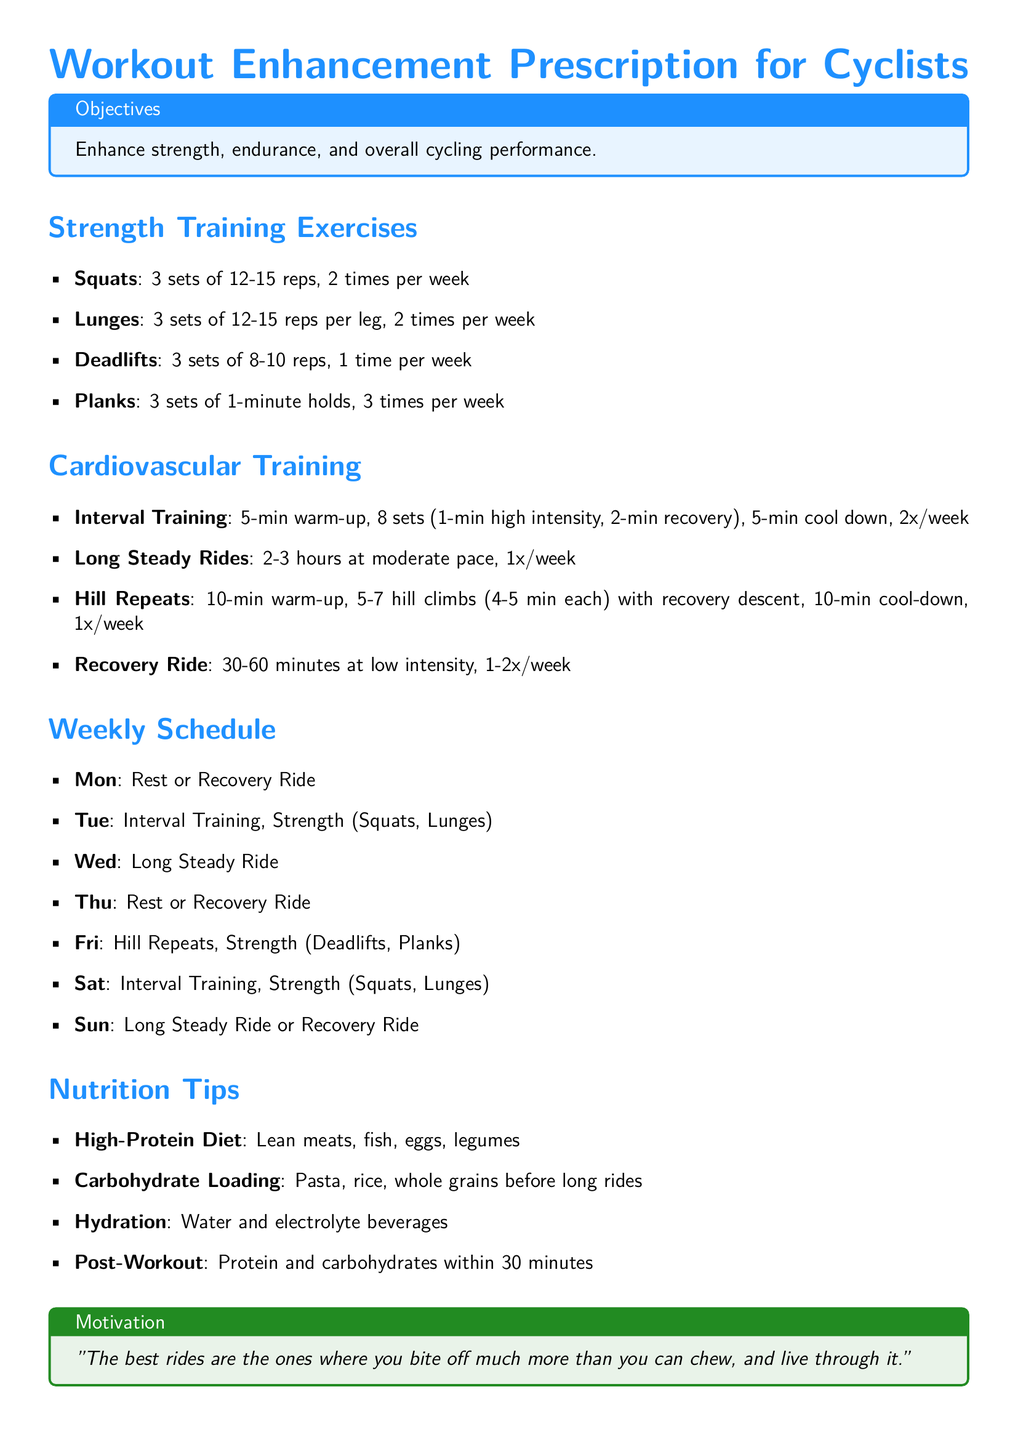What is the primary objective of the workout prescription? The objective stated in the document is to enhance strength, endurance, and overall cycling performance.
Answer: Enhance strength, endurance, and overall cycling performance How many sets of lunges should be performed per week? The document specifies that lunges should be performed for 3 sets, 2 times per week.
Answer: 2 times per week What is the duration for the long steady rides? The document indicates that long steady rides should be 2-3 hours at a moderate pace.
Answer: 2-3 hours How many hill climbs are recommended during hill repeats? The recommendation for hill repeats is 5-7 hill climbs as stated in the document.
Answer: 5-7 hill climbs When should post-workout nutrition be consumed? The document states post-workout nutrition should be consumed within 30 minutes.
Answer: Within 30 minutes What type of training is suggested for Tuesdays? The document outlines that Tuesdays should include interval training and strength exercises (squats and lunges).
Answer: Interval Training, Strength (Squats, Lunges) How often should planks be performed per week? According to the document, planks should be performed 3 times per week.
Answer: 3 times per week What is the color used in the title of the document? The document uses cycling blue as the color for the title.
Answer: cycling blue 